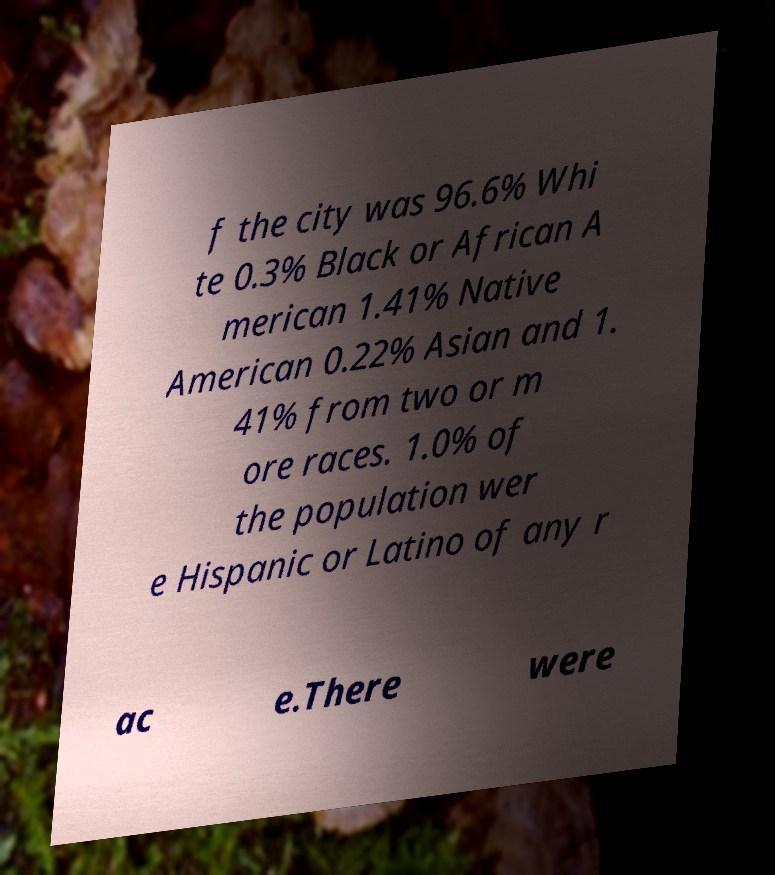I need the written content from this picture converted into text. Can you do that? f the city was 96.6% Whi te 0.3% Black or African A merican 1.41% Native American 0.22% Asian and 1. 41% from two or m ore races. 1.0% of the population wer e Hispanic or Latino of any r ac e.There were 